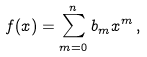Convert formula to latex. <formula><loc_0><loc_0><loc_500><loc_500>f ( x ) = \sum _ { m = 0 } ^ { n } b _ { m } x ^ { m } \, ,</formula> 